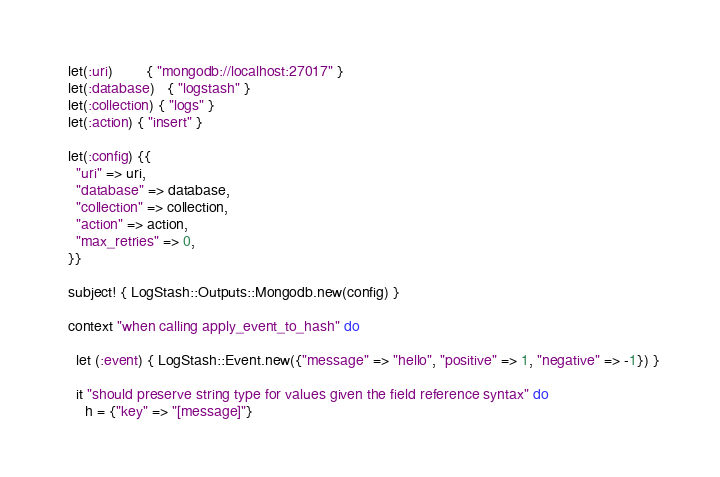<code> <loc_0><loc_0><loc_500><loc_500><_Ruby_>  let(:uri)        { "mongodb://localhost:27017" }
  let(:database)   { "logstash" }
  let(:collection) { "logs" }
  let(:action) { "insert" }

  let(:config) {{
    "uri" => uri,
    "database" => database,
    "collection" => collection,
    "action" => action,
    "max_retries" => 0,
  }}

  subject! { LogStash::Outputs::Mongodb.new(config) }

  context "when calling apply_event_to_hash" do

    let (:event) { LogStash::Event.new({"message" => "hello", "positive" => 1, "negative" => -1}) }

    it "should preserve string type for values given the field reference syntax" do
      h = {"key" => "[message]"}</code> 